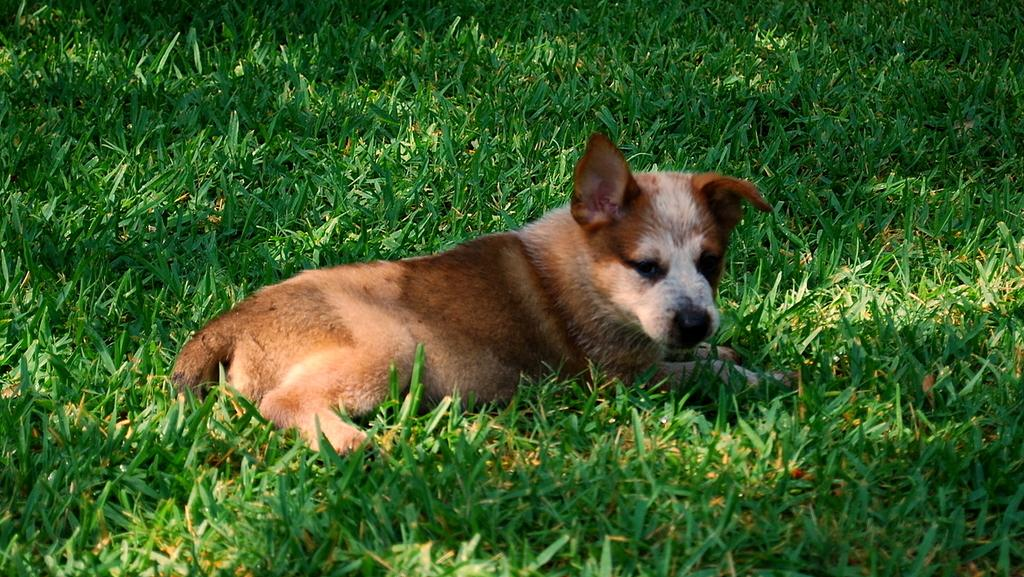What animal can be seen in the image? There is a dog in the image. Where is the dog located? The dog is sitting on the grass. What is the position of the dog in the image? The dog is in the center of the image. What type of jar is the dog holding in the image? There is no jar present in the image; the dog is sitting on the grass. 